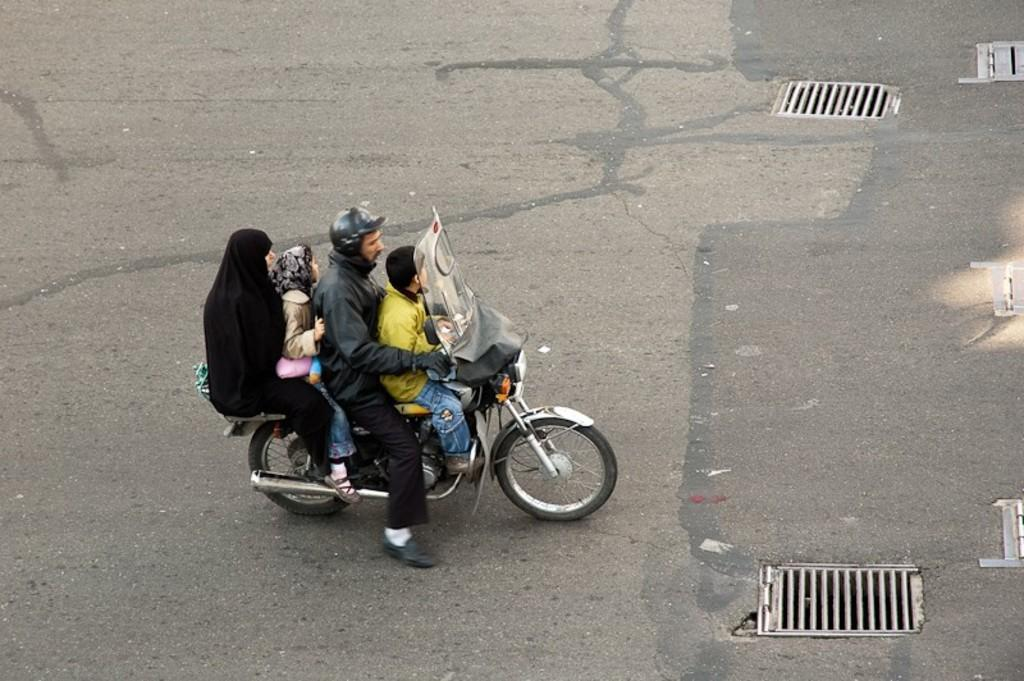How many people are in the image? There are two persons and two children in the image. What are they doing in the image? They are on a bike. Where is the bike located? The bike is on the road. Is anyone wearing protective gear in the image? Yes, one of the men is wearing a helmet. What type of cabbage is being used as a hat by one of the children in the image? There is no cabbage or hat present on any of the children in the image. Is there a horn attached to the bike in the image? There is no horn visible on the bike in the image. 